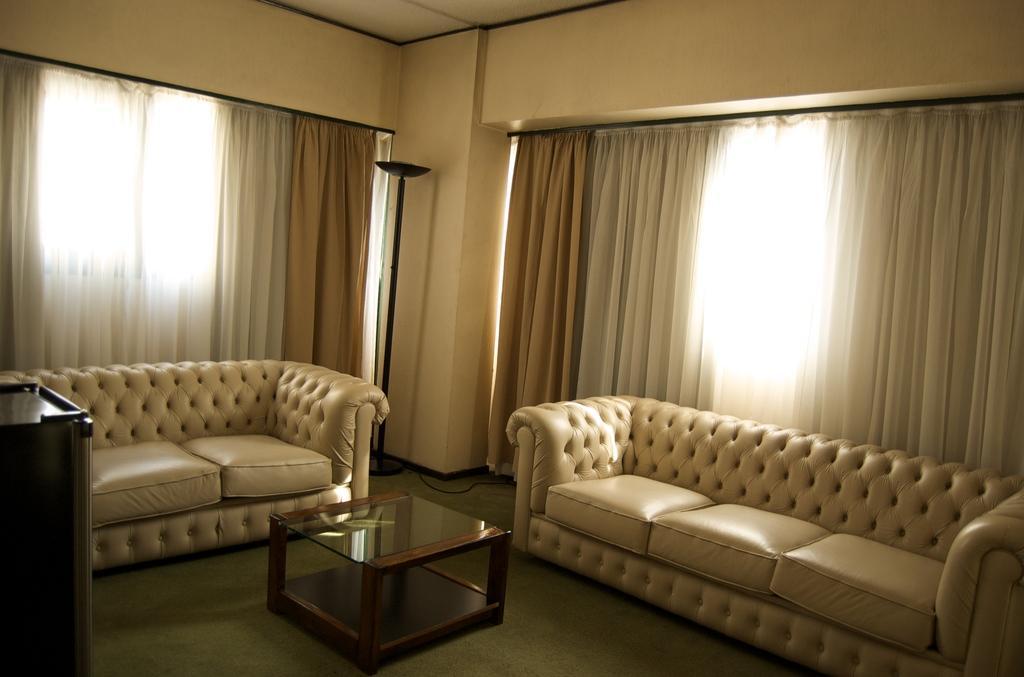Could you give a brief overview of what you see in this image? This is a picture taken in a room, in this room there are two sofas. In the middle of the room there is a tea table which is made up of glass and wood and background of the sofas are a white curtains and wall. 